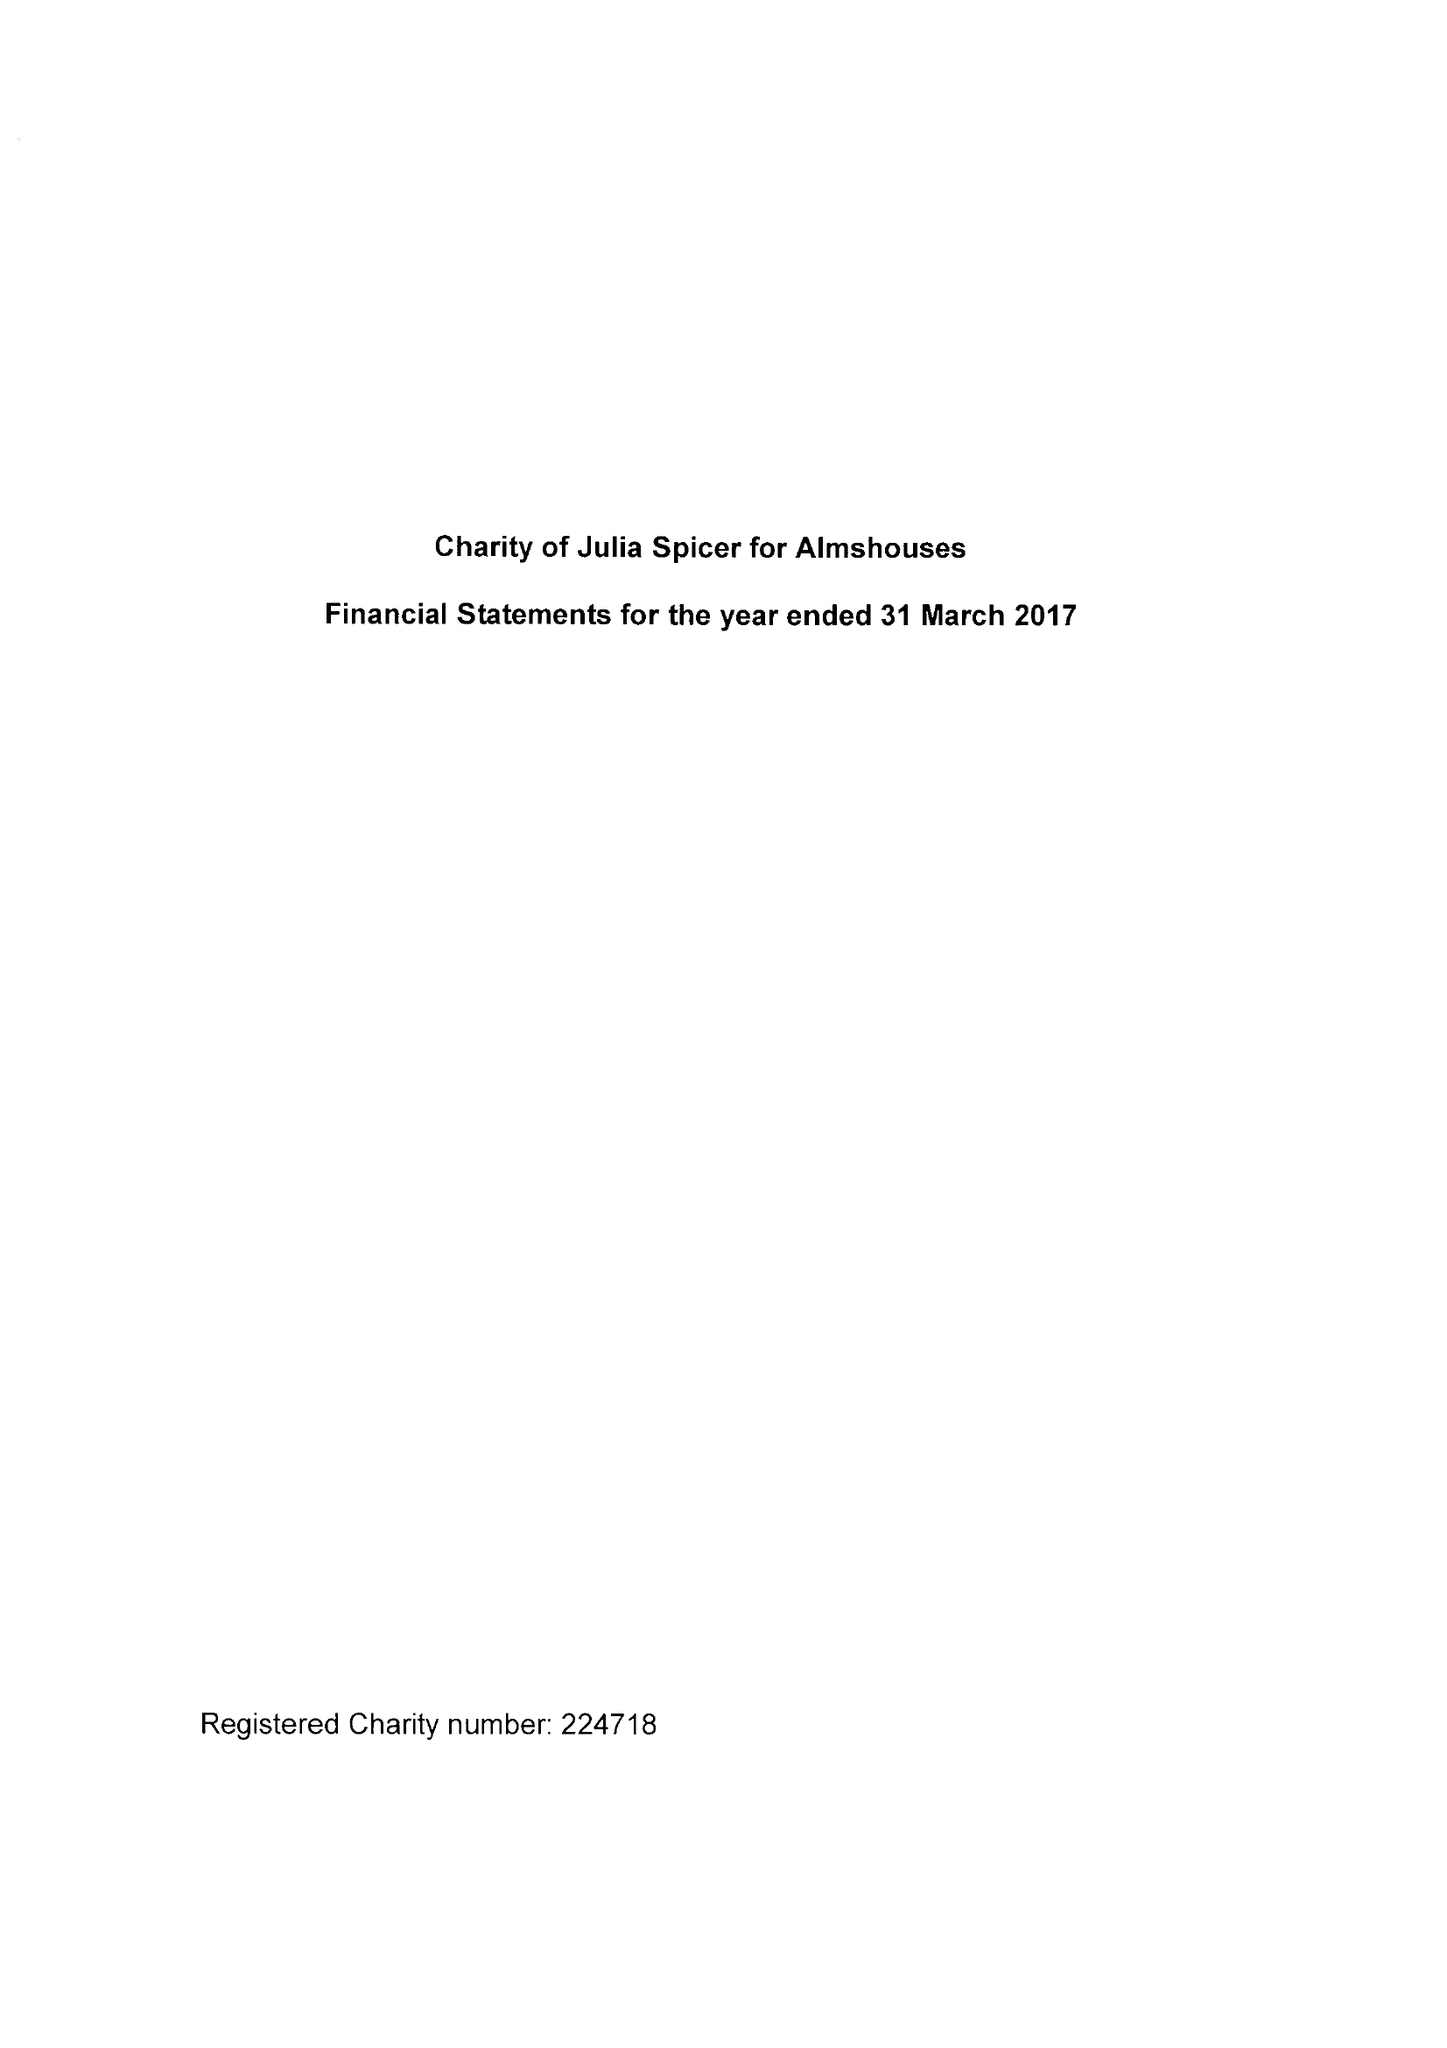What is the value for the address__street_line?
Answer the question using a single word or phrase. 125 HIGH STREET 